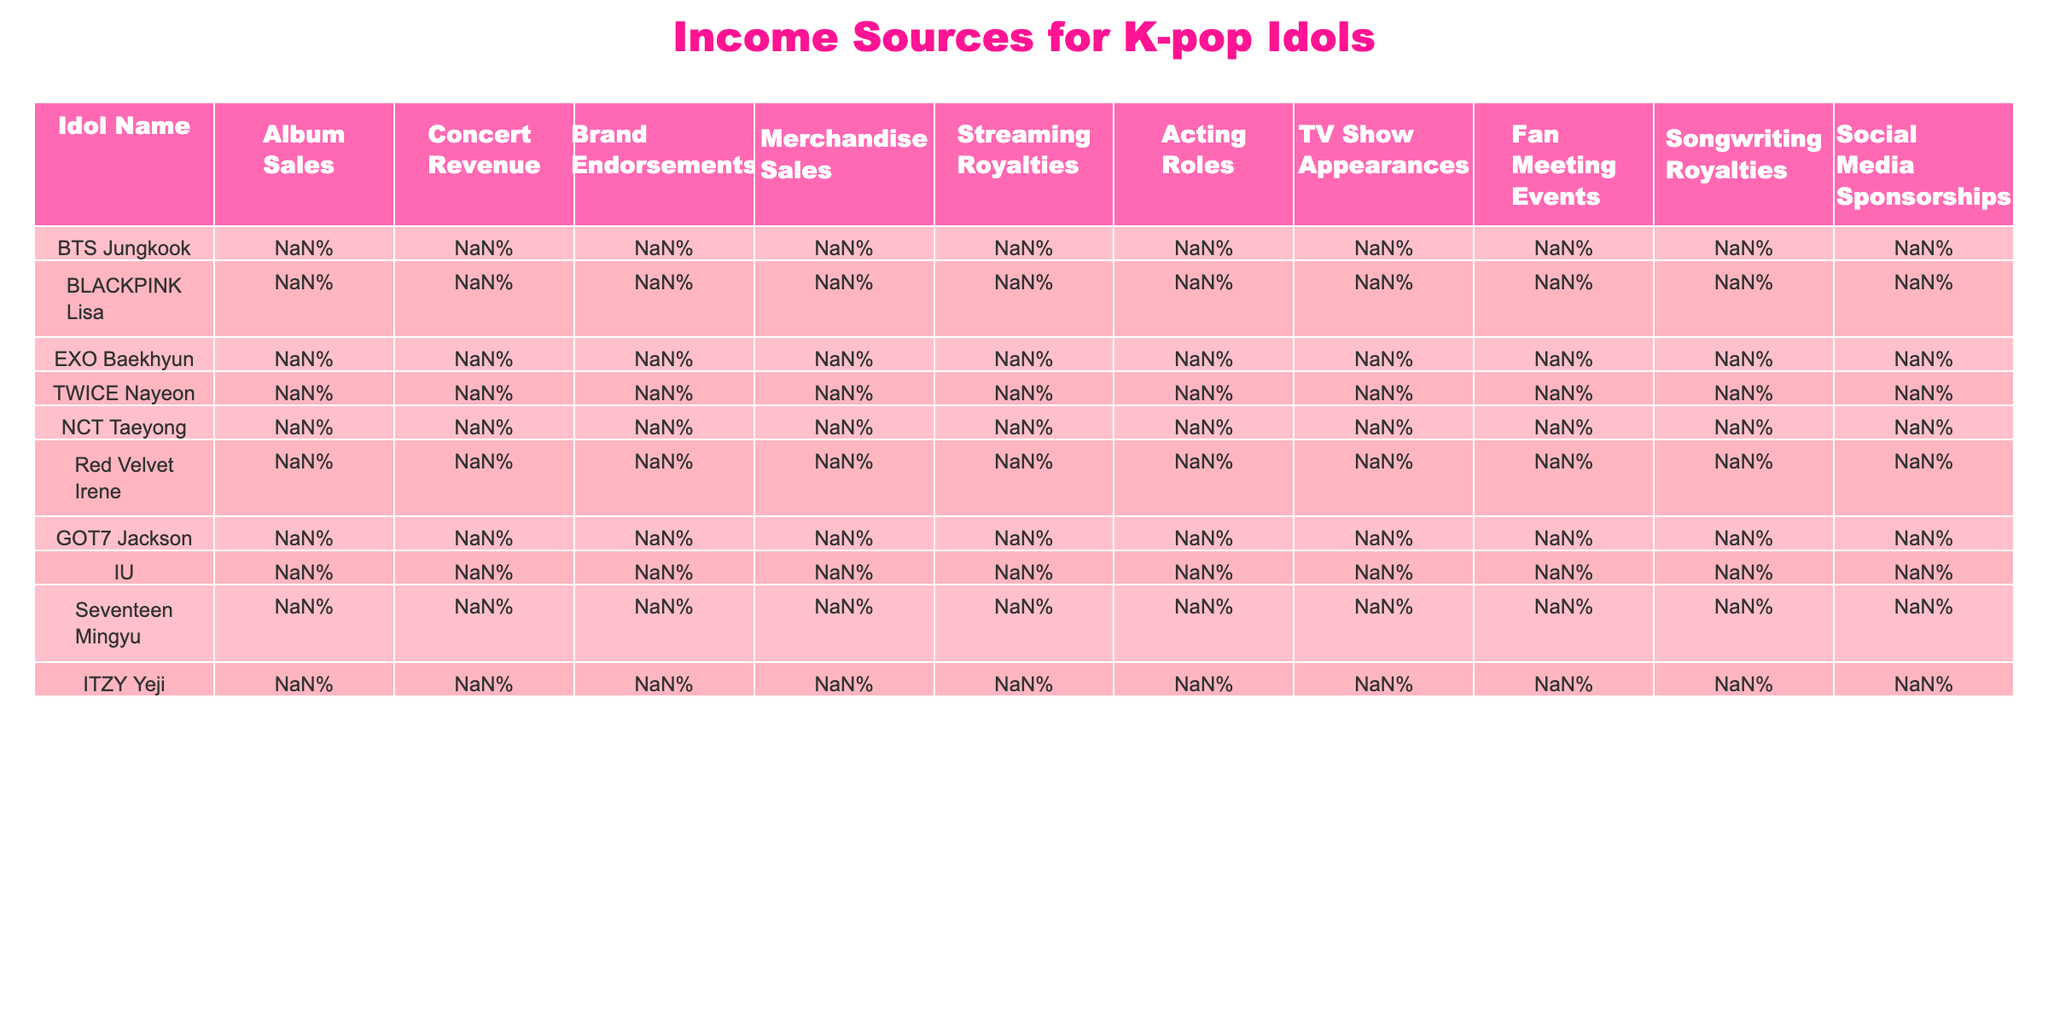What percentage of income does BTS Jungkook earn from Album Sales? Referring to the table, BTS Jungkook earns 35% of his income from Album Sales.
Answer: 35% Which idol has the highest revenue from Brand Endorsements? From the table, GOT7 Jackson has the highest revenue from Brand Endorsements at 22%.
Answer: 22% What is the total percentage of income from Concert Revenue and Merchandise Sales for BLACKPINK Lisa? BLACKPINK Lisa earns 20% from Concert Revenue and 8% from Merchandise Sales. Adding these values gives 20% + 8% = 28%.
Answer: 28% Is it true that Red Velvet Irene earns more from TV Show Appearances than from Streaming Royalties? Red Velvet Irene earns 12% from TV Show Appearances and 5% from Streaming Royalties. Since 12% is greater than 5%, the statement is true.
Answer: Yes Which idol earns the least from Fan Meeting Events, and what is that percentage? Looking at the table, GOT7 Jackson earns 4% from Fan Meeting Events, which is the lowest compared to others.
Answer: 4% What is the average percentage of income from Acting Roles for all idols listed? Calculating the sum of Acting Roles percentages: 2 + 5 + 8 + 4 + 6 + 12 + 10 + 15 + 3 + 4 = 69%. Dividing by 10 (the number of idols) gives an average of 69% / 10 = 6.9%.
Answer: 6.9% Which idol has the lowest total income from Concert Revenue and Streaming Royalties combined? The idol with the lowest totals is IU, who earns 12% from Concert Revenue and 10% from Streaming Royalties. Adding these gives 12% + 10% = 22%, which is the lowest.
Answer: 22% On average, what percentage do idols earn from Social Media Sponsorships? The Social Media Sponsorship percentages are: 2, 4, 2, 4, 3, 7, 3, 4; summing these gives 29%. Dividing by 8 (the number of idols) gives an average of 29% / 8 = 3.625%.
Answer: 3.625% Who earns the most from Streaming Royalties, and what is the percentage? Referring to the table, IU earns the most from Streaming Royalties at 10%.
Answer: 10% Is it true that NCT Taeyong earns more from Merchandise Sales than from Songwriting Royalties? NCT Taeyong earns 11% from Merchandise Sales and 4% from Songwriting Royalties. Since 11% is greater than 4%, the statement is true.
Answer: Yes Calculate the difference in income from Album Sales between the highest and lowest earning idols. BTS Jungkook earns 35% from Album Sales, while IU earns 15%. The difference is 35% - 15% = 20%.
Answer: 20% 